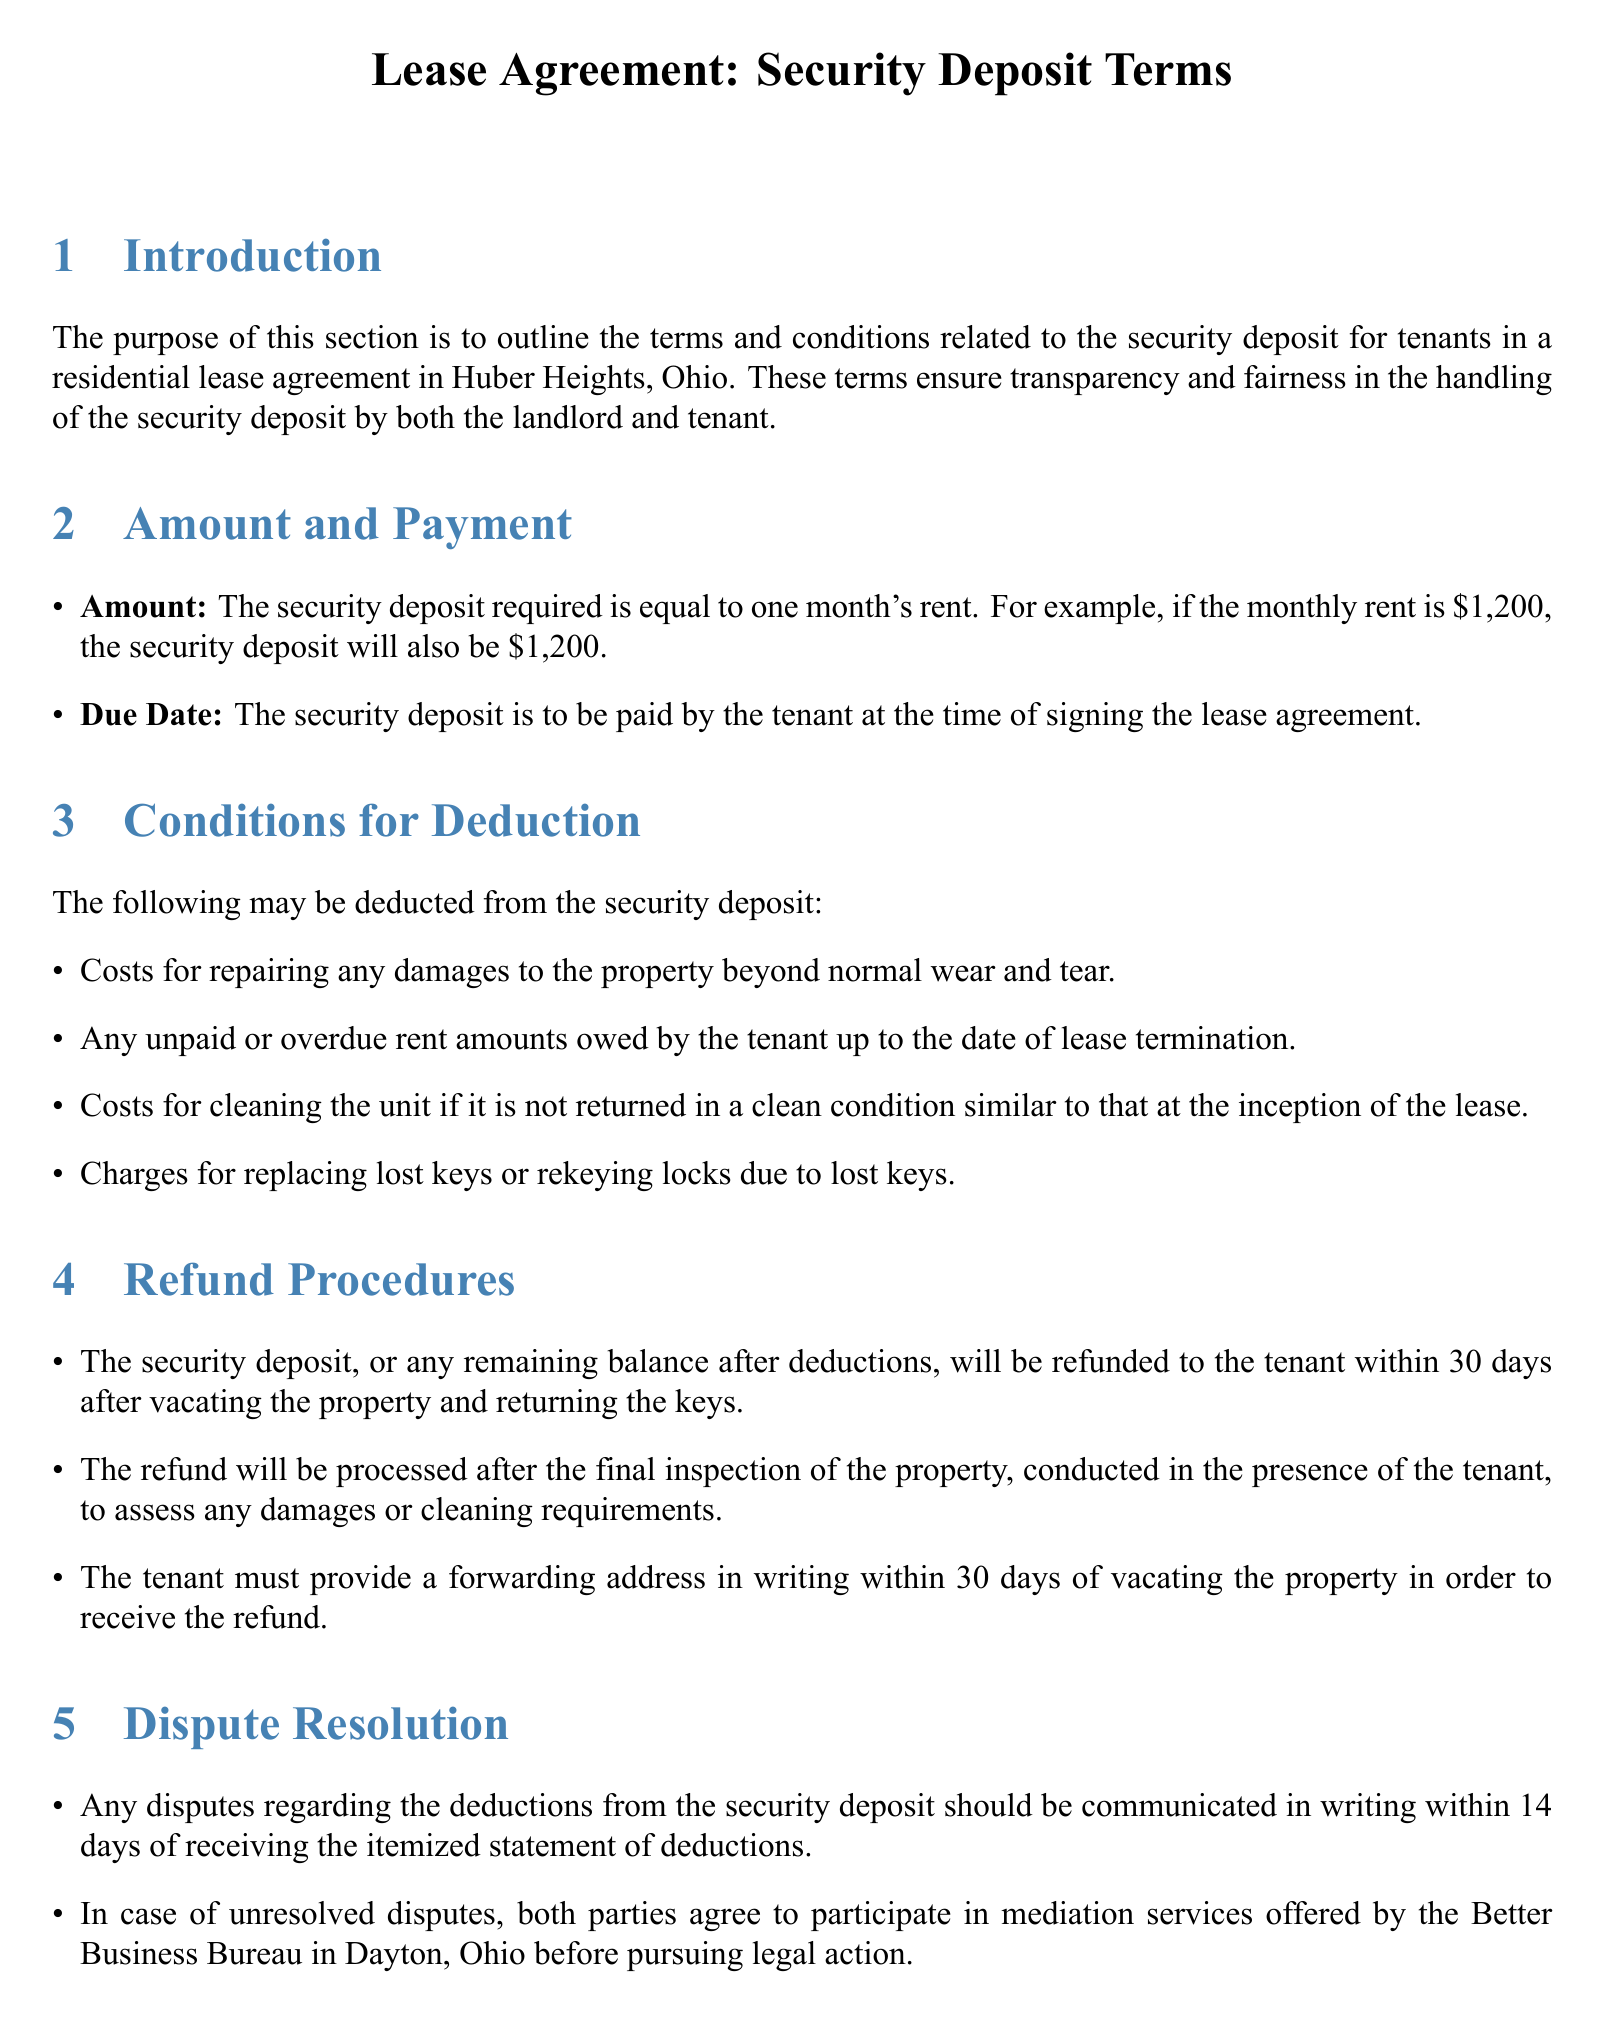What is the amount of the security deposit? The security deposit is equal to one month's rent, which is specified in the document.
Answer: one month's rent When is the security deposit due? The document specifies that the deposit is due at the time of signing the lease agreement.
Answer: at the time of signing What may be deducted from the security deposit? The document lists several items that may be deducted, requiring the retrieval of specific listed items.
Answer: costs for damages, unpaid rent, cleaning, lost keys How long does the landlord have to refund the security deposit? The document indicates a time frame for refunding the deposit after the tenant vacates the property.
Answer: 30 days What should the tenant provide to receive the refund? The document specifies what the tenant must do to facilitate the refund process.
Answer: a forwarding address in writing What is the initial condition required for the rented unit upon vacating? The terms mention a condition related to the cleanliness of the unit to avoid deductions.
Answer: clean condition What action must the tenant take regarding disputes about deductions? The document outlines the required communication method for disputes and its timeframe.
Answer: communicate in writing within 14 days Who is the landlord? The document provides the name of the landlord managing the property.
Answer: John Doe Properties 